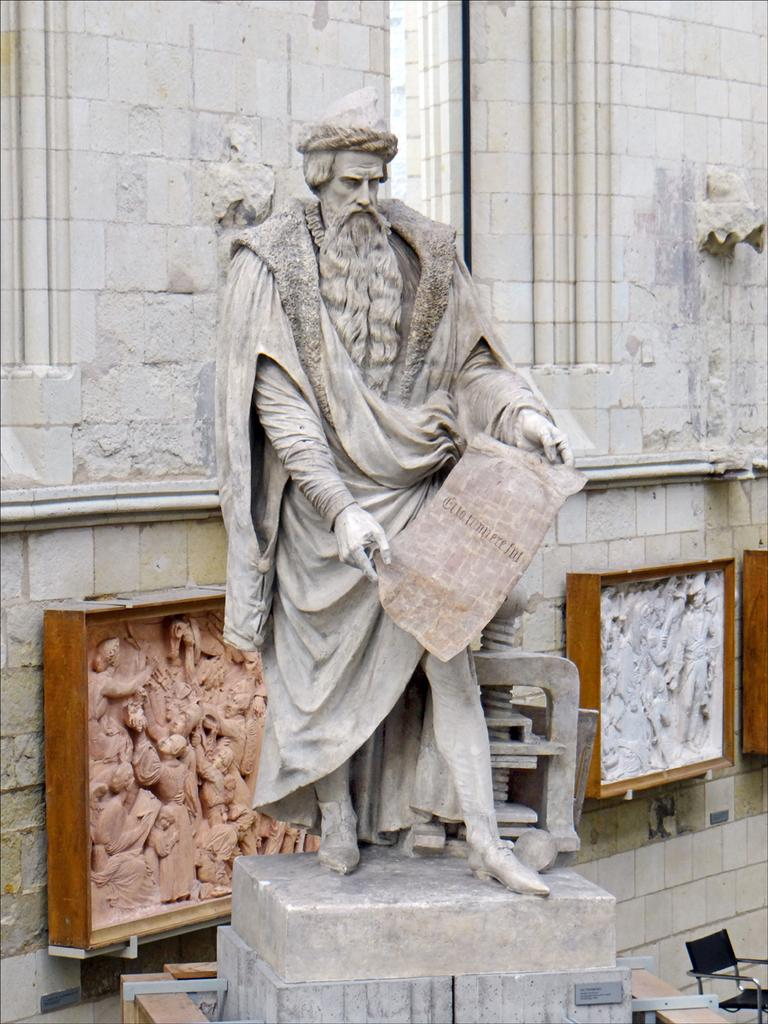What is the main subject in the image? There is a statue in the image. Can you describe the background of the image? There is decor on the wall in the background of the image. What type of cracker is being used to support the statue in the image? There is no cracker present in the image, and the statue does not require support. 